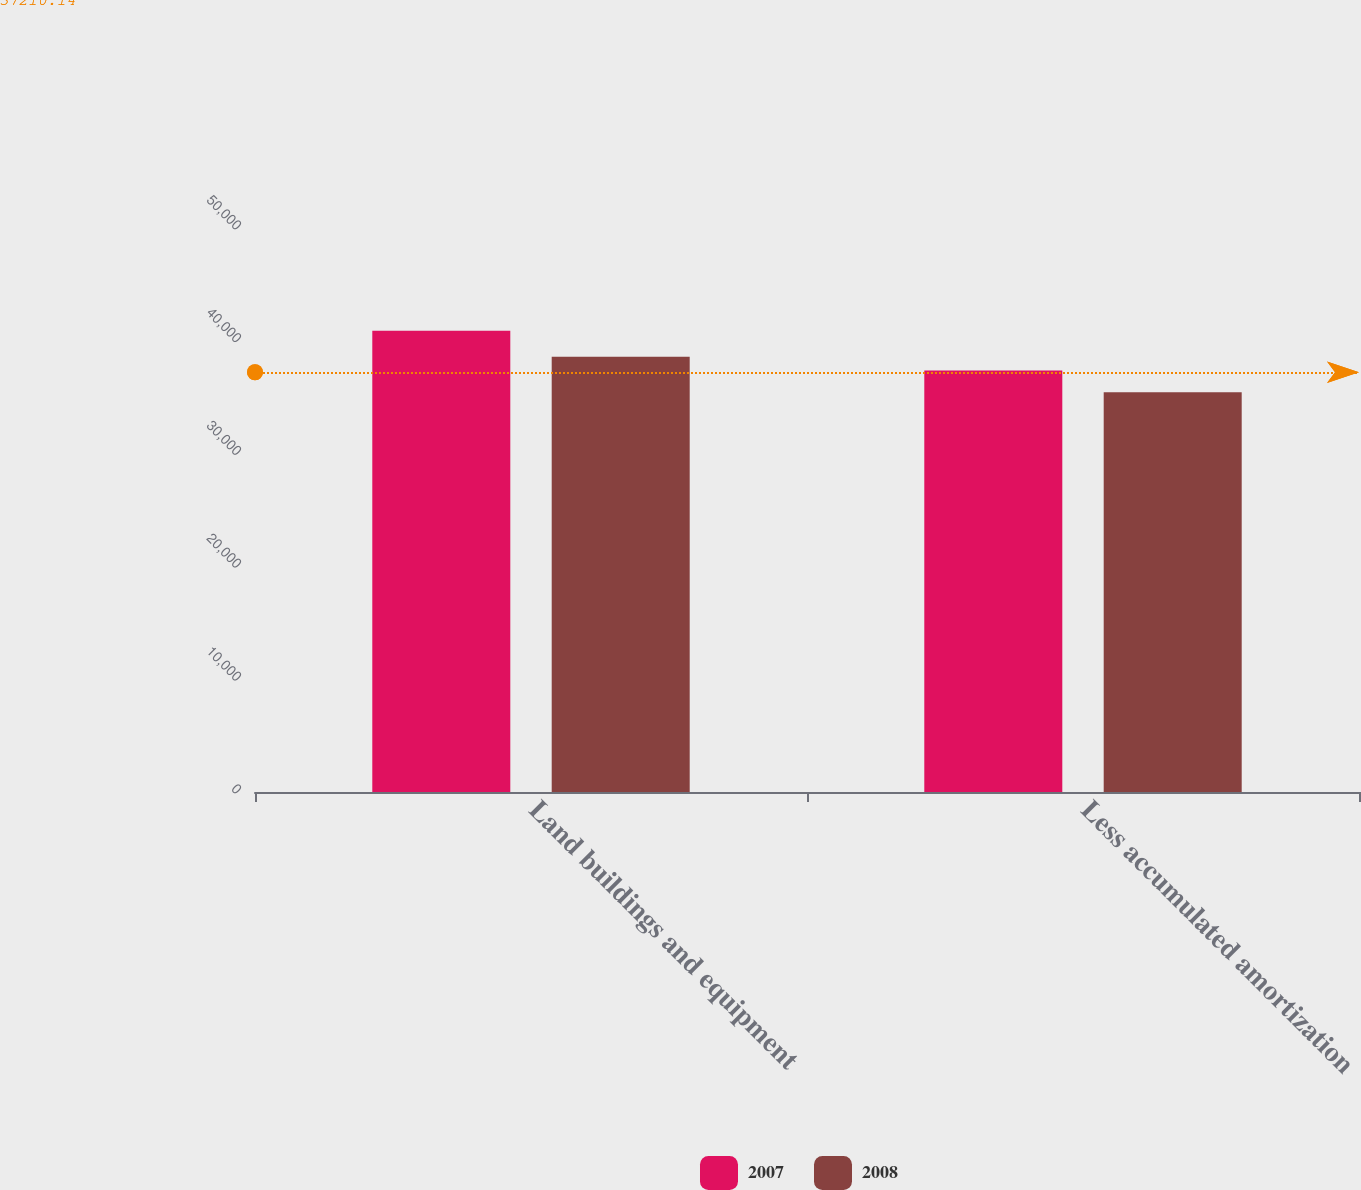Convert chart to OTSL. <chart><loc_0><loc_0><loc_500><loc_500><stacked_bar_chart><ecel><fcel>Land buildings and equipment<fcel>Less accumulated amortization<nl><fcel>2007<fcel>40880<fcel>37363<nl><fcel>2008<fcel>38584<fcel>35446<nl></chart> 